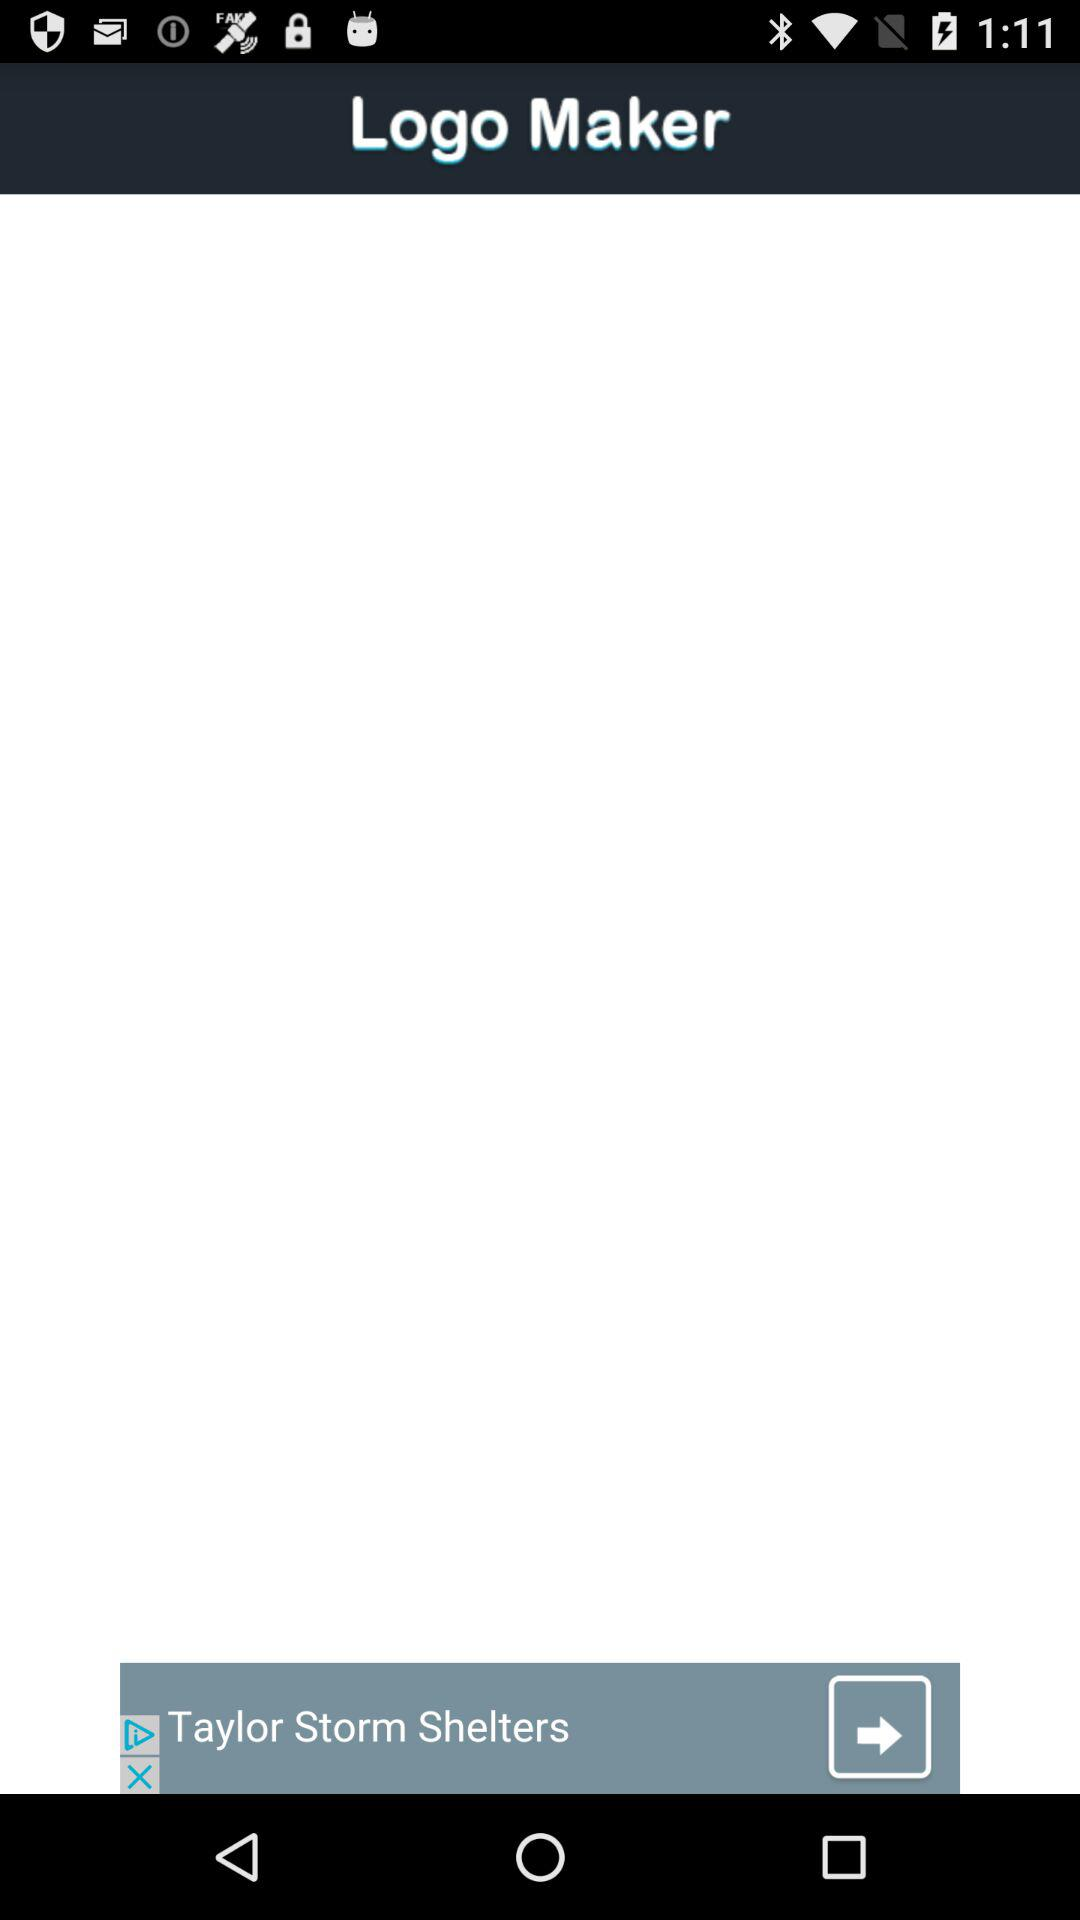What is the application name? The application name is "Logo Maker". 